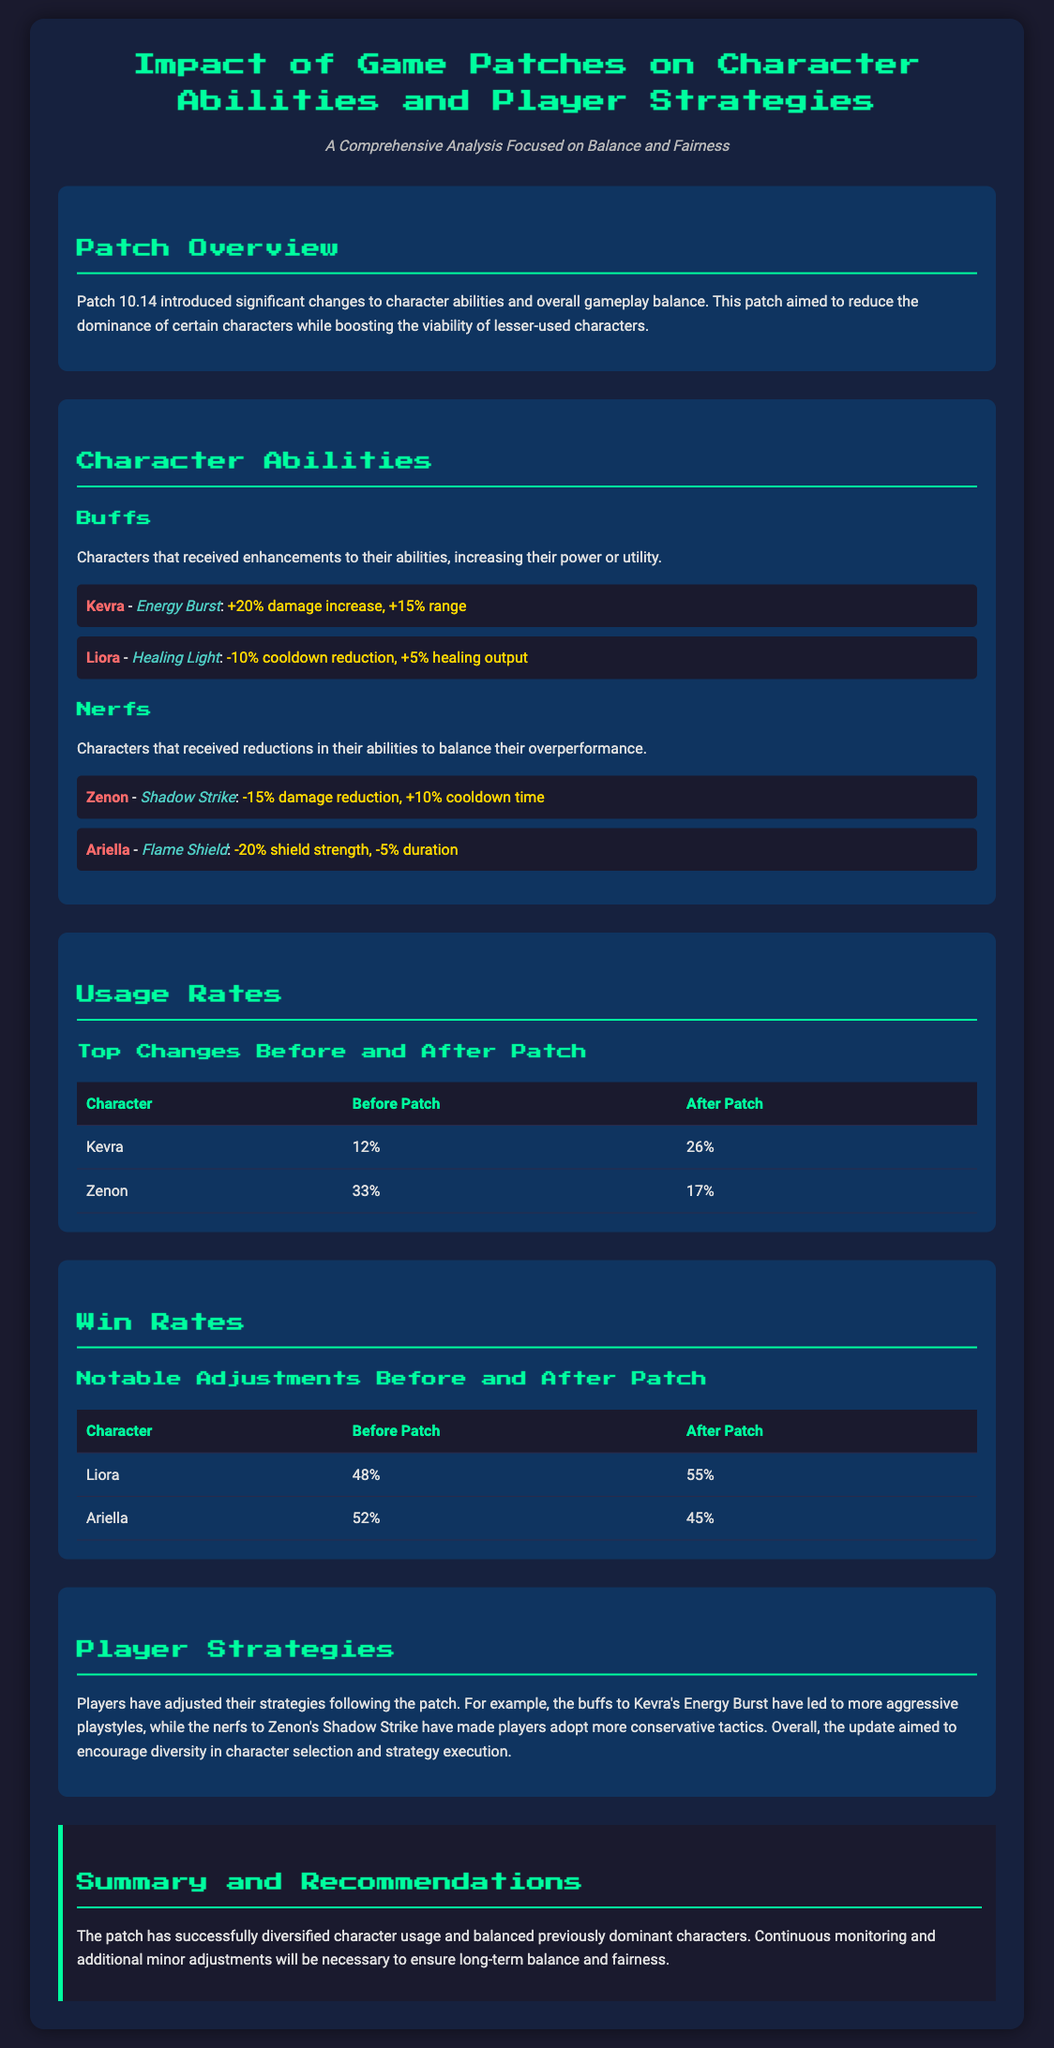What character received a buff to Energy Burst? The character that received a buff to Energy Burst is specifically mentioned in the buffs section of the document.
Answer: Kevra What is the usage rate of Zenon before the patch? The usage rate of Zenon before the patch is listed in the usage rates table.
Answer: 33% What percentage increase did Liora's win rate experience after the patch? Liora's win rate before the patch was 48% and after the patch it was 55%, an increase of 7%.
Answer: 7% Which character suffered a damage reduction as a nerf? The nerfs section indicates which characters received reductions.
Answer: Zenon What is the overall aim of Patch 10.14 as stated in the document? The document provides a summary of the patch's objectives in the overview section.
Answer: Balance What was the win rate of Ariella before the patch? Ariella's win rate before the patch is provided in the win rates table.
Answer: 52% What change was made to Kevra's Energy Burst? The change made to Kevra's Energy Burst is specified as a buff in the document.
Answer: +20% damage increase, +15% range What strategy shift occurred due to the patch? The document describes how players adjusted their strategies following the patch.
Answer: Diversified playstyles What is the theme of the document? The theme or focus of the document can be deduced from the title and subtitle.
Answer: Balance and fairness 